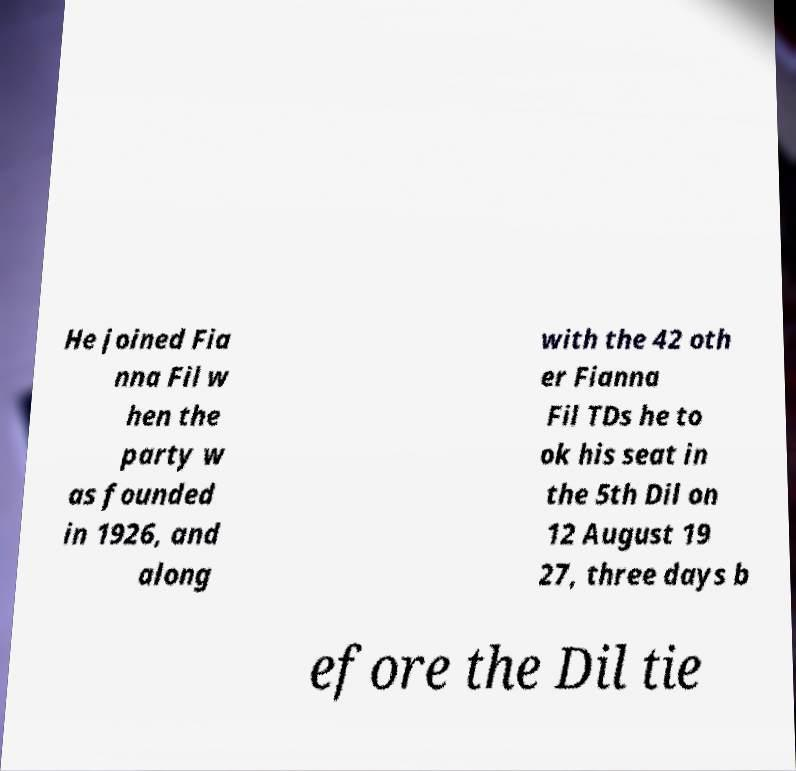Could you assist in decoding the text presented in this image and type it out clearly? He joined Fia nna Fil w hen the party w as founded in 1926, and along with the 42 oth er Fianna Fil TDs he to ok his seat in the 5th Dil on 12 August 19 27, three days b efore the Dil tie 